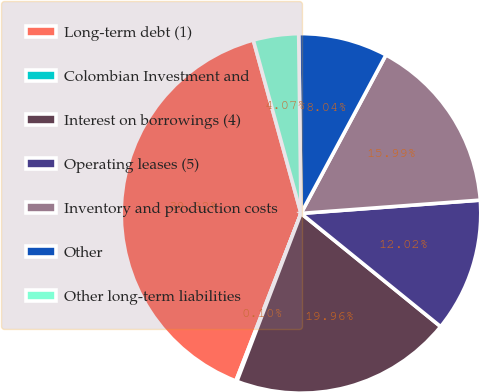Convert chart to OTSL. <chart><loc_0><loc_0><loc_500><loc_500><pie_chart><fcel>Long-term debt (1)<fcel>Colombian Investment and<fcel>Interest on borrowings (4)<fcel>Operating leases (5)<fcel>Inventory and production costs<fcel>Other<fcel>Other long-term liabilities<nl><fcel>39.82%<fcel>0.1%<fcel>19.96%<fcel>12.02%<fcel>15.99%<fcel>8.04%<fcel>4.07%<nl></chart> 